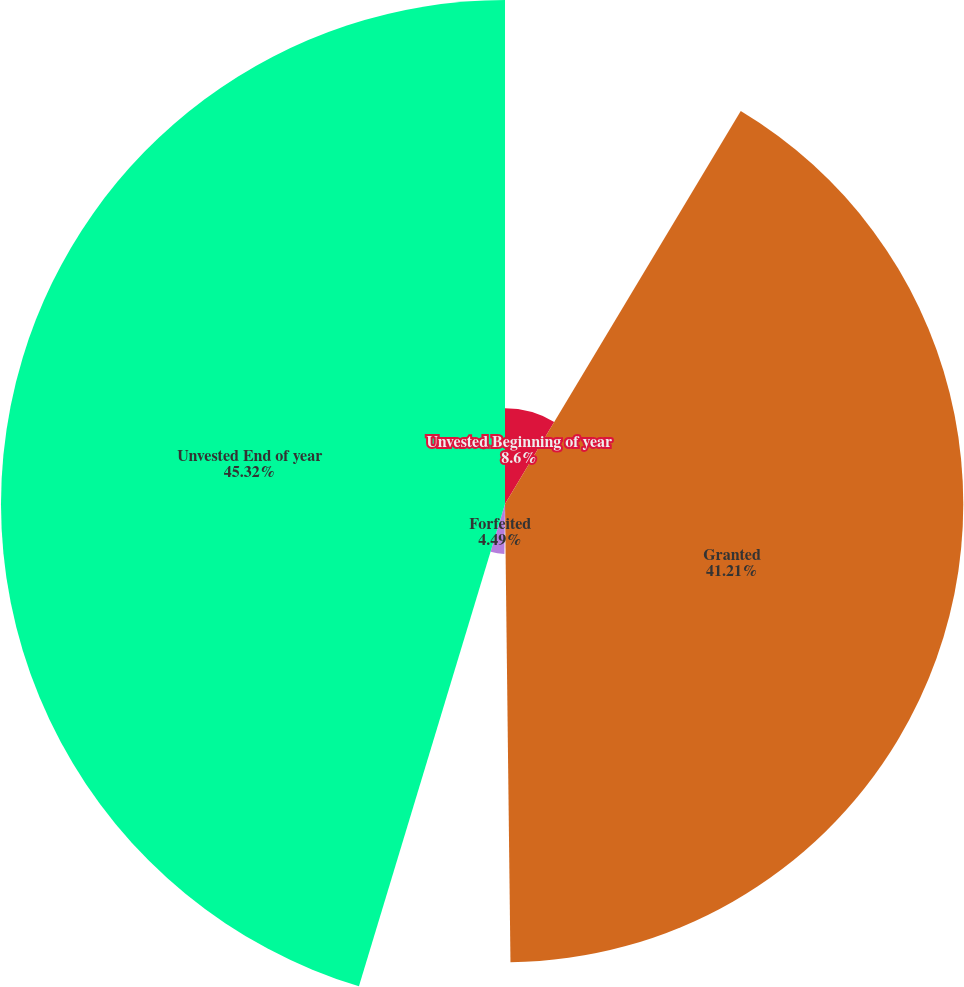<chart> <loc_0><loc_0><loc_500><loc_500><pie_chart><fcel>Unvested Beginning of year<fcel>Granted<fcel>Vested(a)<fcel>Forfeited<fcel>Unvested End of year<nl><fcel>8.6%<fcel>41.21%<fcel>0.38%<fcel>4.49%<fcel>45.32%<nl></chart> 